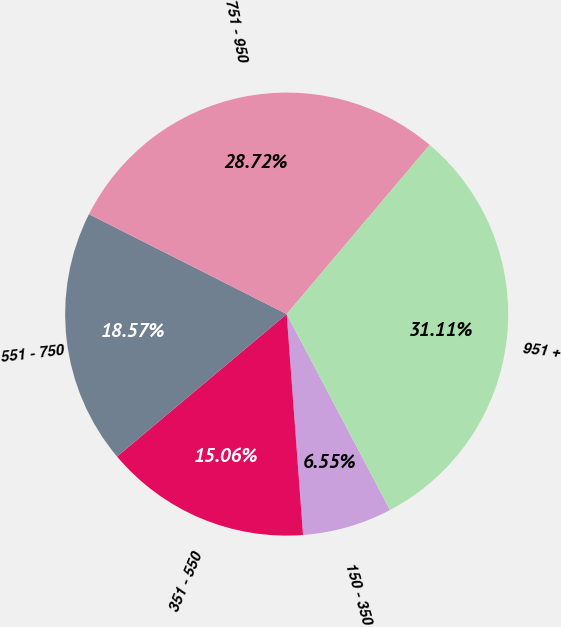Convert chart. <chart><loc_0><loc_0><loc_500><loc_500><pie_chart><fcel>150 - 350<fcel>351 - 550<fcel>551 - 750<fcel>751 - 950<fcel>951 +<nl><fcel>6.55%<fcel>15.06%<fcel>18.57%<fcel>28.72%<fcel>31.11%<nl></chart> 